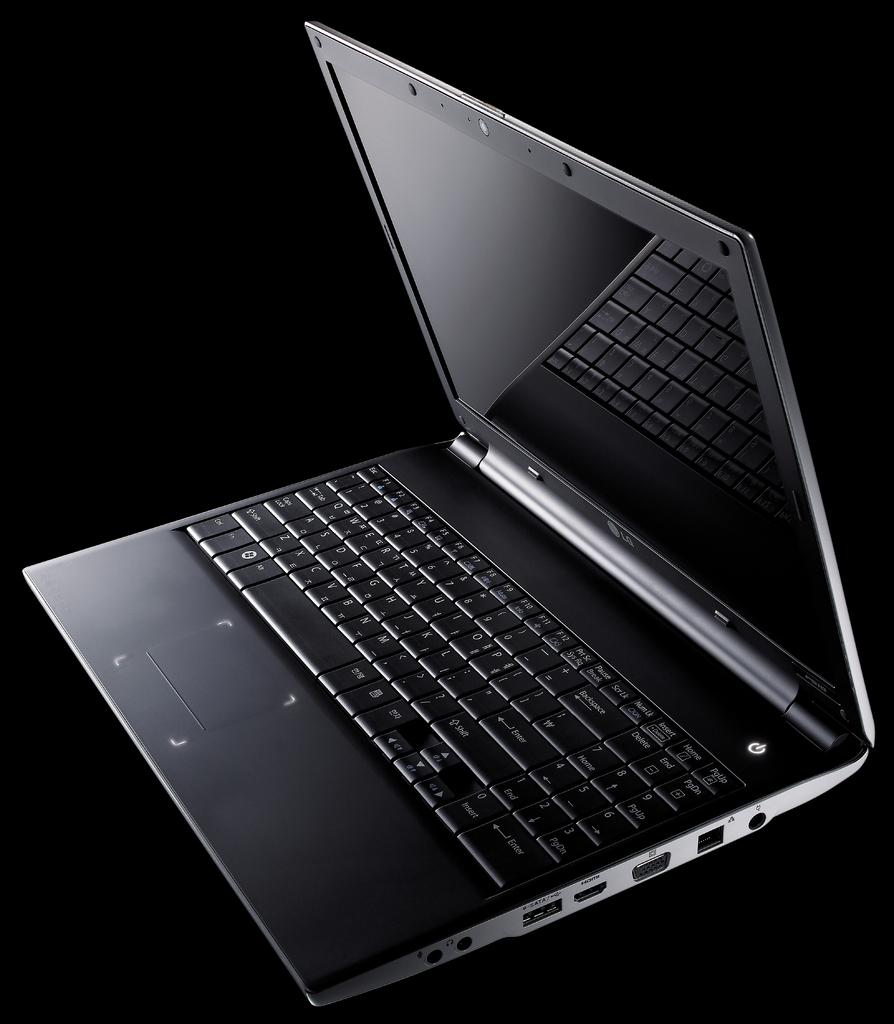<image>
Render a clear and concise summary of the photo. A Black background with a LG laptop in it 